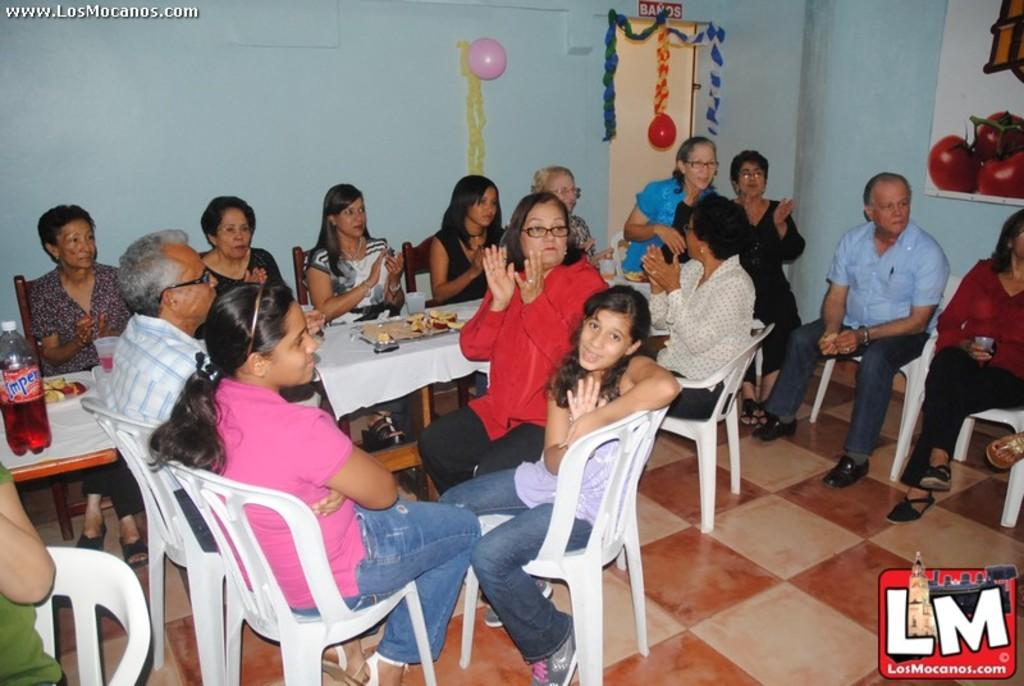What can be seen in the background of the image? There is a wall in the image. What decorative items are present in the image? There are balloons in the image. What are the people in the image doing? There are people sitting on chairs in the image. What furniture is visible in the image? There is a table in the image. What items can be seen on the table? There is a plate and a bottle on the table. What type of produce is being divided among the family members in the image? There is no produce or family members present in the image. What type of division is taking place in the image? There is no division taking place in the image; the people are sitting on chairs and there are balloons, a table, a plate, and a bottle present. 